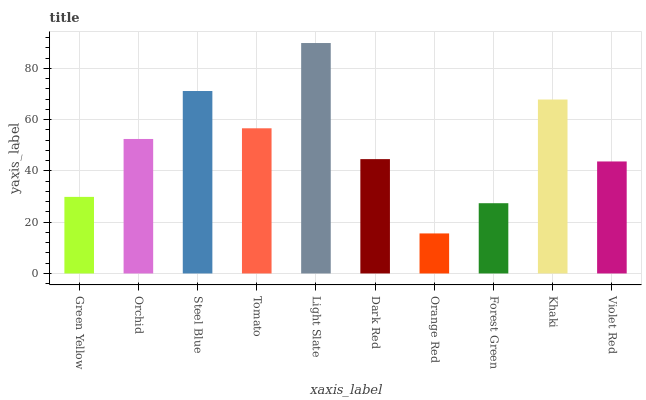Is Orange Red the minimum?
Answer yes or no. Yes. Is Light Slate the maximum?
Answer yes or no. Yes. Is Orchid the minimum?
Answer yes or no. No. Is Orchid the maximum?
Answer yes or no. No. Is Orchid greater than Green Yellow?
Answer yes or no. Yes. Is Green Yellow less than Orchid?
Answer yes or no. Yes. Is Green Yellow greater than Orchid?
Answer yes or no. No. Is Orchid less than Green Yellow?
Answer yes or no. No. Is Orchid the high median?
Answer yes or no. Yes. Is Dark Red the low median?
Answer yes or no. Yes. Is Steel Blue the high median?
Answer yes or no. No. Is Orange Red the low median?
Answer yes or no. No. 